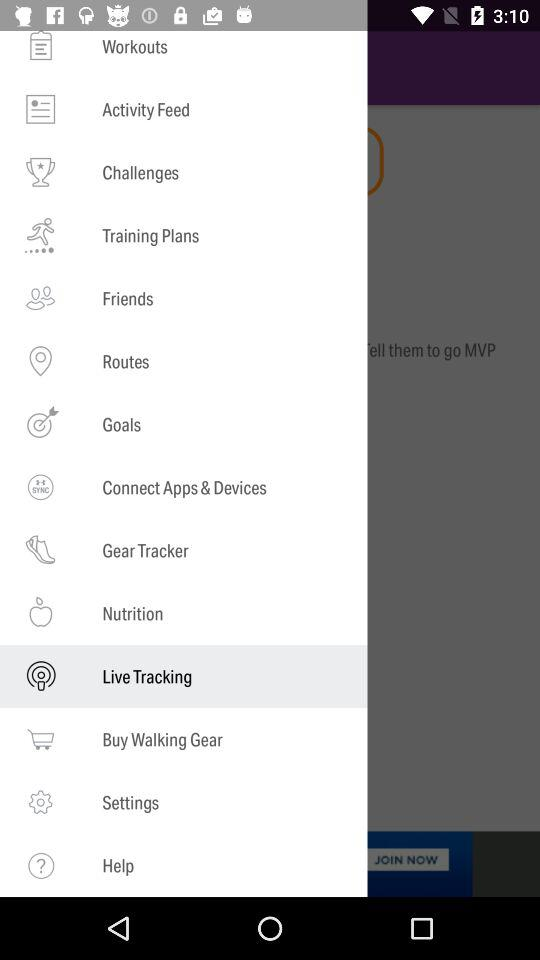Which is the selected item in the menu? The selected item in the menu is "Live Tracking". 